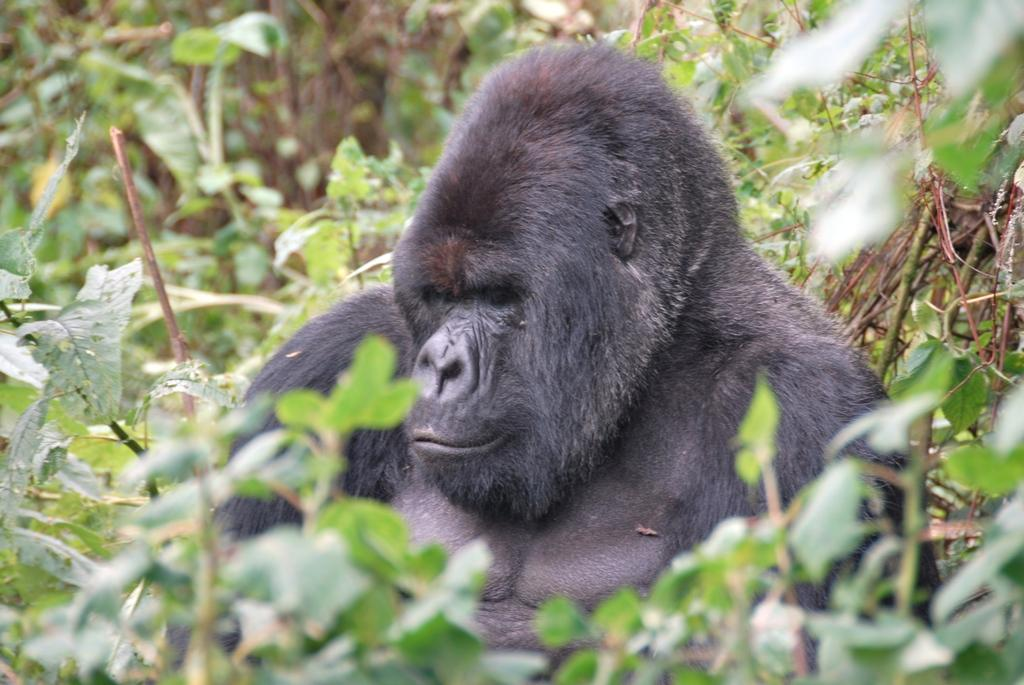What is the main subject of the image? There is an animal in the center of the image. What color is the animal? The animal is black in color. What can be seen in the background of the image? There are plants in the background of the image. What type of hose can be seen in the image? There is no hose present in the image. What is the texture of the animal's fur in the image? The provided facts do not mention the texture of the animal's fur, so we cannot determine its texture from the image. 